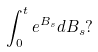Convert formula to latex. <formula><loc_0><loc_0><loc_500><loc_500>\int _ { 0 } ^ { t } e ^ { B _ { s } } d B _ { s } ?</formula> 